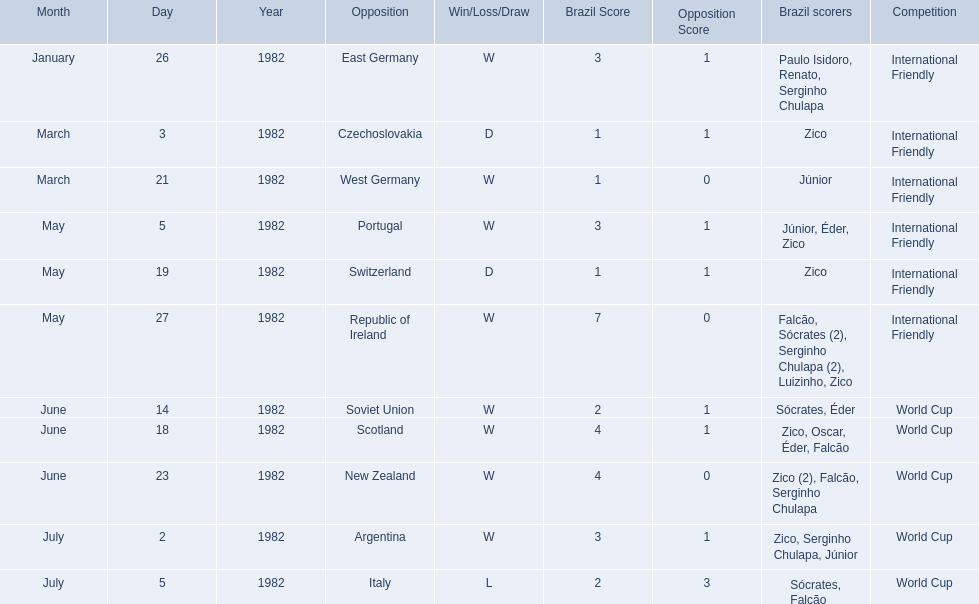Write the full table. {'header': ['Month', 'Day', 'Year', 'Opposition', 'Win/Loss/Draw', 'Brazil Score', 'Opposition Score', 'Brazil scorers', 'Competition'], 'rows': [['January', '26', '1982', 'East Germany', 'W', '3', '1', 'Paulo Isidoro, Renato, Serginho Chulapa', 'International Friendly'], ['March', '3', '1982', 'Czechoslovakia', 'D', '1', '1', 'Zico', 'International Friendly'], ['March', '21', '1982', 'West Germany', 'W', '1', '0', 'Júnior', 'International Friendly'], ['May', '5', '1982', 'Portugal', 'W', '3', '1', 'Júnior, Éder, Zico', 'International Friendly'], ['May', '19', '1982', 'Switzerland', 'D', '1', '1', 'Zico', 'International Friendly'], ['May', '27', '1982', 'Republic of Ireland', 'W', '7', '0', 'Falcão, Sócrates (2), Serginho Chulapa (2), Luizinho, Zico', 'International Friendly'], ['June', '14', '1982', 'Soviet Union', 'W', '2', '1', 'Sócrates, Éder', 'World Cup'], ['June', '18', '1982', 'Scotland', 'W', '4', '1', 'Zico, Oscar, Éder, Falcão', 'World Cup'], ['June', '23', '1982', 'New Zealand', 'W', '4', '0', 'Zico (2), Falcão, Serginho Chulapa', 'World Cup'], ['July', '2', '1982', 'Argentina', 'W', '3', '1', 'Zico, Serginho Chulapa, Júnior', 'World Cup'], ['July', '5', '1982', 'Italy', 'L', '2', '3', 'Sócrates, Falcão', 'World Cup']]} What were the scores of each of game in the 1982 brazilian football games? 3-1, 1-1, 1-0, 3-1, 1-1, 7-0, 2-1, 4-1, 4-0, 3-1, 2-3. Of those, which were scores from games against portugal and the soviet union? 3-1, 2-1. And between those two games, against which country did brazil score more goals? Portugal. 